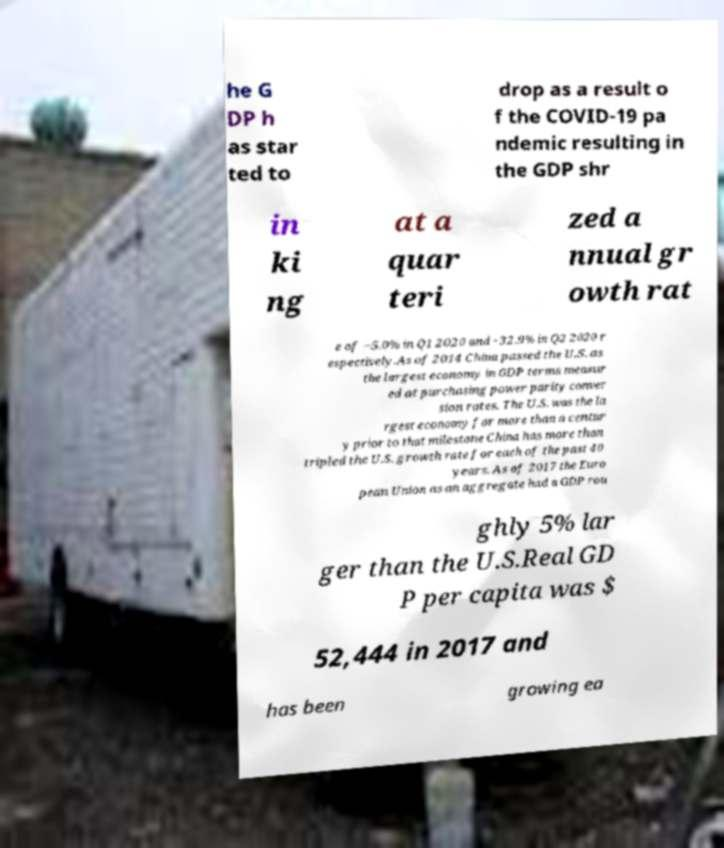I need the written content from this picture converted into text. Can you do that? he G DP h as star ted to drop as a result o f the COVID-19 pa ndemic resulting in the GDP shr in ki ng at a quar teri zed a nnual gr owth rat e of −5.0% in Q1 2020 and −32.9% in Q2 2020 r espectively.As of 2014 China passed the U.S. as the largest economy in GDP terms measur ed at purchasing power parity conver sion rates. The U.S. was the la rgest economy for more than a centur y prior to that milestone China has more than tripled the U.S. growth rate for each of the past 40 years. As of 2017 the Euro pean Union as an aggregate had a GDP rou ghly 5% lar ger than the U.S.Real GD P per capita was $ 52,444 in 2017 and has been growing ea 